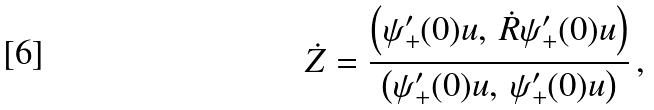Convert formula to latex. <formula><loc_0><loc_0><loc_500><loc_500>\dot { Z } = \frac { \left ( \psi _ { + } ^ { \prime } ( 0 ) u , \, \dot { R } \psi _ { + } ^ { \prime } ( 0 ) u \right ) } { \left ( \psi _ { + } ^ { \prime } ( 0 ) u , \, \psi _ { + } ^ { \prime } ( 0 ) u \right ) } \, ,</formula> 